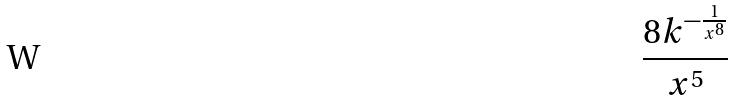<formula> <loc_0><loc_0><loc_500><loc_500>\frac { 8 k ^ { - \frac { 1 } { x ^ { 8 } } } } { x ^ { 5 } }</formula> 